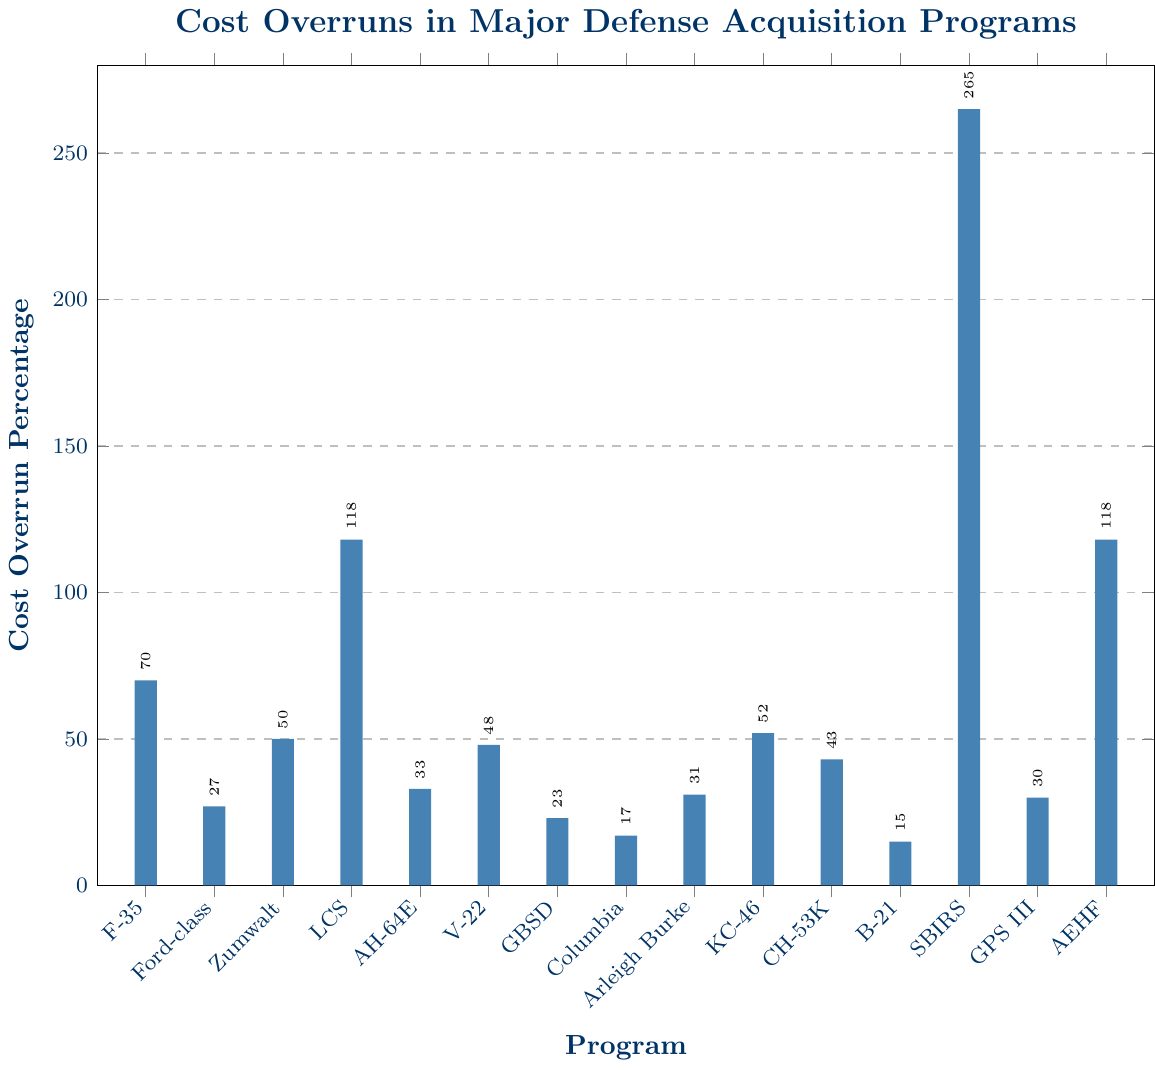What's the cost overrun for the program with the highest value? The highest bar represents the program with the highest cost overrun. It is the Space-Based Infrared System with a cost overrun percentage of 265%.
Answer: 265% Which programs have a cost overrun of more than 100%? Look at the bars exceeding the 100% mark. These are the Littoral Combat Ship, Space-Based Infrared System, and Advanced Extremely High Frequency Satellite.
Answer: Littoral Combat Ship, Space-Based Infrared System, Advanced Extremely High Frequency Satellite What's the average cost overrun of the F-35, Apache AH-64E Helicopter, and KC-46 Tanker programs? Add their cost overruns and divide by the number of programs. The cost overruns are 70%, 33%, and 52% respectively. (70 + 33 + 52) / 3 = 155 / 3 = 51.67%.
Answer: 51.67% How does the cost overrun of the Global Positioning System III compare to the B-21 Raider Bomber? Refer to their respective bars; GPS III is 30% and B-21 is 15%. Compare these values: 30% is greater than 15%.
Answer: GPS III > B-21 Raider Bomber Which program has the smallest cost overrun? Identify the shortest bar, which is the B-21 Raider Bomber with a cost overrun percentage of 15%.
Answer: B-21 Raider Bomber How many programs have a cost overrun percentage of less than 30%? Count the bars shorter than the 30% mark. They are Gerald R. Ford-class Aircraft Carrier, Ground-Based Strategic Deterrent, Columbia-class Submarine, and B-21 Raider Bomber.
Answer: 4 What is the cost difference between the Gerald R. Ford-class Aircraft Carrier and the Arleigh Burke-class Destroyer? Subtract the smaller overrun percentage from the larger one. Gerald R. Ford-class has 27% and Arleigh Burke-class has 31%. 31 - 27 = 4%.
Answer: 4% Which programs have less than or equal to the cost overrun of the Arleigh Burke-class Destroyer? Identify the bars equal to or shorter than 31%, which include Gerald R. Ford-class Aircraft Carrier, Apache AH-64E Helicopter, Ground-Based Strategic Deterrent, Columbia-class Submarine, and B-21 Raider Bomber.
Answer: Gerald R. Ford-class Aircraft Carrier, Apache AH-64E Helicopter, Ground-Based Strategic Deterrent, Columbia-class Submarine, B-21 Raider Bomber Rank the top three programs with the highest cost overruns. Look for the three tallest bars and rank them. The Space-Based Infrared System (265%), Littoral Combat Ship (118%), and Advanced Extremely High Frequency Satellite (118%).
Answer: Space-Based Infrared System, Littoral Combat Ship, Advanced Extremely High Frequency Satellite 